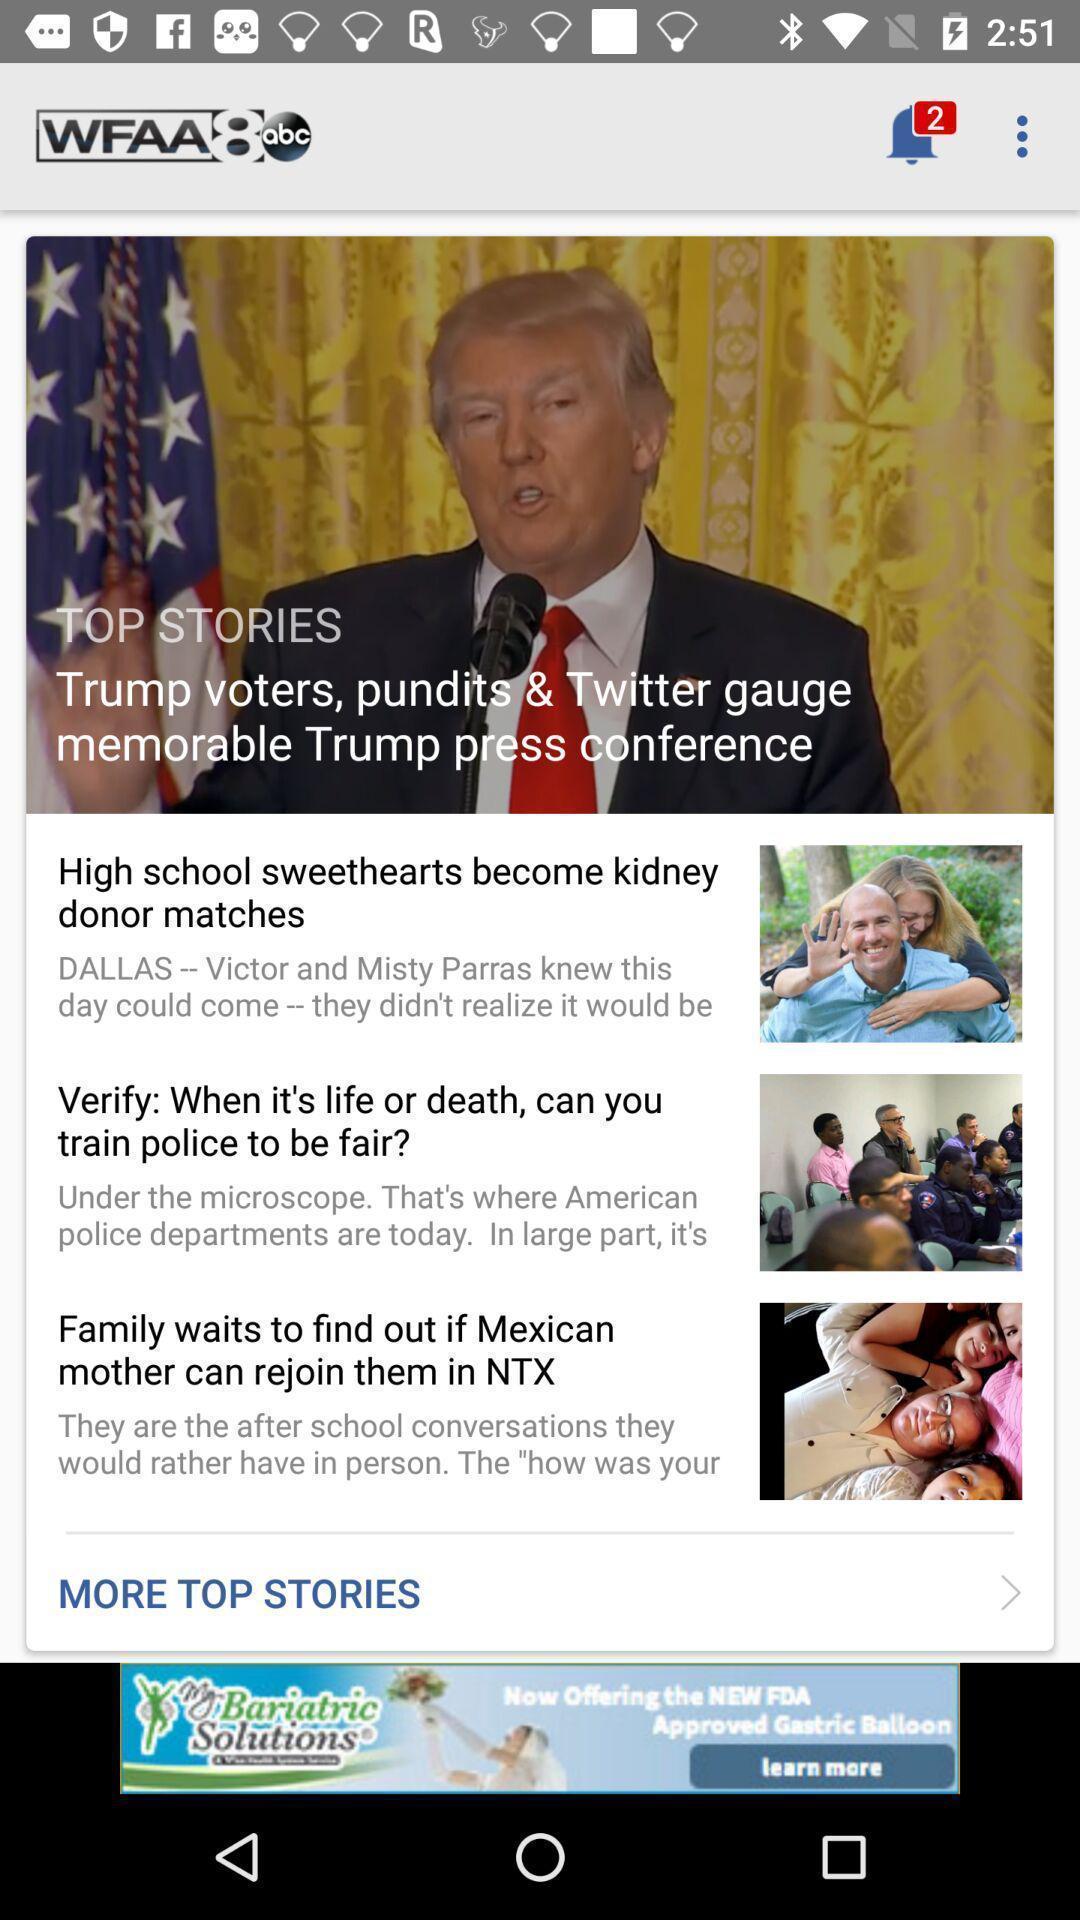Tell me what you see in this picture. Page displaying various news. 